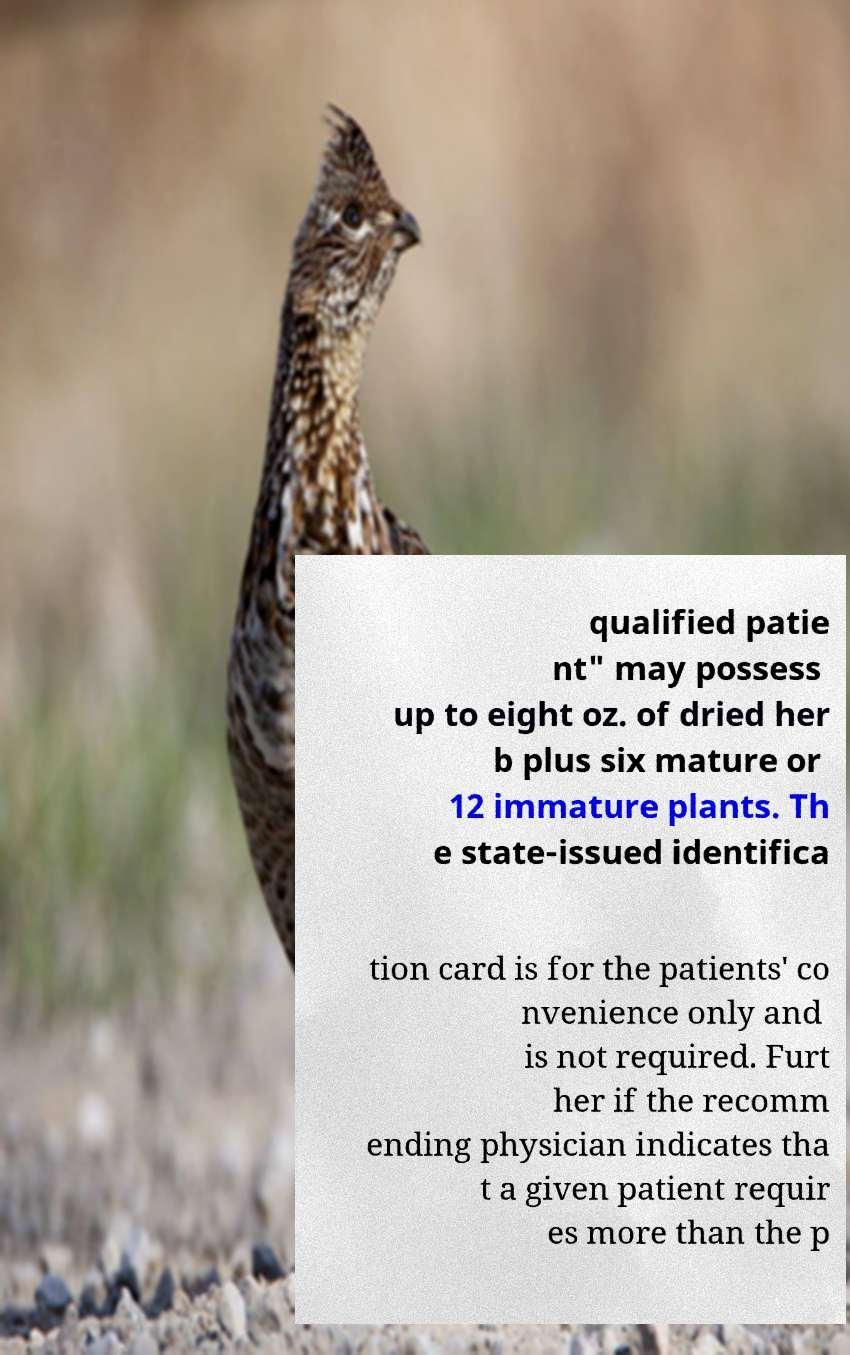For documentation purposes, I need the text within this image transcribed. Could you provide that? qualified patie nt" may possess up to eight oz. of dried her b plus six mature or 12 immature plants. Th e state-issued identifica tion card is for the patients' co nvenience only and is not required. Furt her if the recomm ending physician indicates tha t a given patient requir es more than the p 